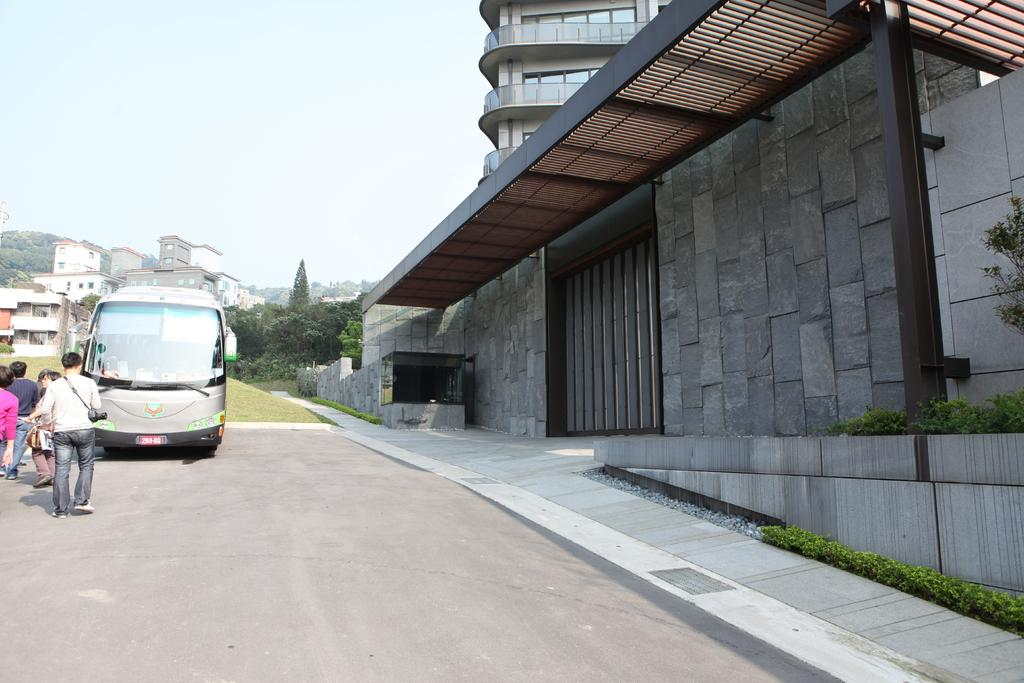What type of structures can be seen in the image? There are buildings in the image. What else is present in the image besides buildings? There is a vehicle and people walking in the image. What type of vegetation is visible in the image? There are trees in the image. What type of airplane can be seen flying in the image? There is no airplane present in the image; it only features buildings, a vehicle, people walking, and trees. What kind of apparatus is being used by the people walking in the image? The image does not show any specific apparatus being used by the people walking; they are simply walking on their own. 